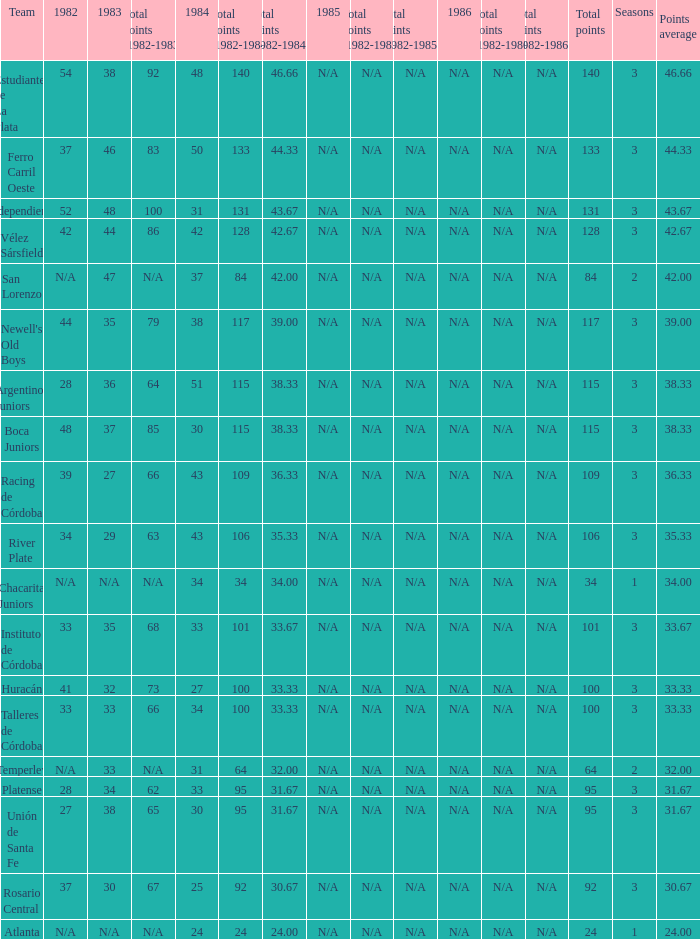What team had 3 seasons and fewer than 27 in 1984? Rosario Central. Would you mind parsing the complete table? {'header': ['Team', '1982', '1983', 'Total points (1982-1983)', '1984', 'Total points (1982-1984)', 'Total points (1982-1984)/3', '1985', 'Total points (1982-1985)', 'Total points (1982-1985)/4', '1986', 'Total points (1982-1986)', 'Total points (1982-1986)/5', 'Total points', 'Seasons', 'Points average'], 'rows': [['Estudiantes de La Plata', '54', '38', '92', '48', '140', '46.66', 'N/A', 'N/A', 'N/A', 'N/A', 'N/A', 'N/A', '140', '3', '46.66'], ['Ferro Carril Oeste', '37', '46', '83', '50', '133', '44.33', 'N/A', 'N/A', 'N/A', 'N/A', 'N/A', 'N/A', '133', '3', '44.33'], ['Independiente', '52', '48', '100', '31', '131', '43.67', 'N/A', 'N/A', 'N/A', 'N/A', 'N/A', 'N/A', '131', '3', '43.67'], ['Vélez Sársfield', '42', '44', '86', '42', '128', '42.67', 'N/A', 'N/A', 'N/A', 'N/A', 'N/A', 'N/A', '128', '3', '42.67'], ['San Lorenzo', 'N/A', '47', 'N/A', '37', '84', '42.00', 'N/A', 'N/A', 'N/A', 'N/A', 'N/A', 'N/A', '84', '2', '42.00'], ["Newell's Old Boys", '44', '35', '79', '38', '117', '39.00', 'N/A', 'N/A', 'N/A', 'N/A', 'N/A', 'N/A', '117', '3', '39.00'], ['Argentinos Juniors', '28', '36', '64', '51', '115', '38.33', 'N/A', 'N/A', 'N/A', 'N/A', 'N/A', 'N/A', '115', '3', '38.33'], ['Boca Juniors', '48', '37', '85', '30', '115', '38.33', 'N/A', 'N/A', 'N/A', 'N/A', 'N/A', 'N/A', '115', '3', '38.33'], ['Racing de Córdoba', '39', '27', '66', '43', '109', '36.33', 'N/A', 'N/A', 'N/A', 'N/A', 'N/A', 'N/A', '109', '3', '36.33'], ['River Plate', '34', '29', '63', '43', '106', '35.33', 'N/A', 'N/A', 'N/A', 'N/A', 'N/A', 'N/A', '106', '3', '35.33'], ['Chacarita Juniors', 'N/A', 'N/A', 'N/A', '34', '34', '34.00', 'N/A', 'N/A', 'N/A', 'N/A', 'N/A', 'N/A', '34', '1', '34.00'], ['Instituto de Córdoba', '33', '35', '68', '33', '101', '33.67', 'N/A', 'N/A', 'N/A', 'N/A', 'N/A', 'N/A', '101', '3', '33.67'], ['Huracán', '41', '32', '73', '27', '100', '33.33', 'N/A', 'N/A', 'N/A', 'N/A', 'N/A', 'N/A', '100', '3', '33.33'], ['Talleres de Córdoba', '33', '33', '66', '34', '100', '33.33', 'N/A', 'N/A', 'N/A', 'N/A', 'N/A', 'N/A', '100', '3', '33.33'], ['Temperley', 'N/A', '33', 'N/A', '31', '64', '32.00', 'N/A', 'N/A', 'N/A', 'N/A', 'N/A', 'N/A', '64', '2', '32.00'], ['Platense', '28', '34', '62', '33', '95', '31.67', 'N/A', 'N/A', 'N/A', 'N/A', 'N/A', 'N/A', '95', '3', '31.67'], ['Unión de Santa Fe', '27', '38', '65', '30', '95', '31.67', 'N/A', 'N/A', 'N/A', 'N/A', 'N/A', 'N/A', '95', '3', '31.67'], ['Rosario Central', '37', '30', '67', '25', '92', '30.67', 'N/A', 'N/A', 'N/A', 'N/A', 'N/A', 'N/A', '92', '3', '30.67'], ['Atlanta', 'N/A', 'N/A', 'N/A', '24', '24', '24.00', 'N/A', 'N/A', 'N/A', 'N/A', 'N/A', 'N/A', '24', '1', '24.00']]} 